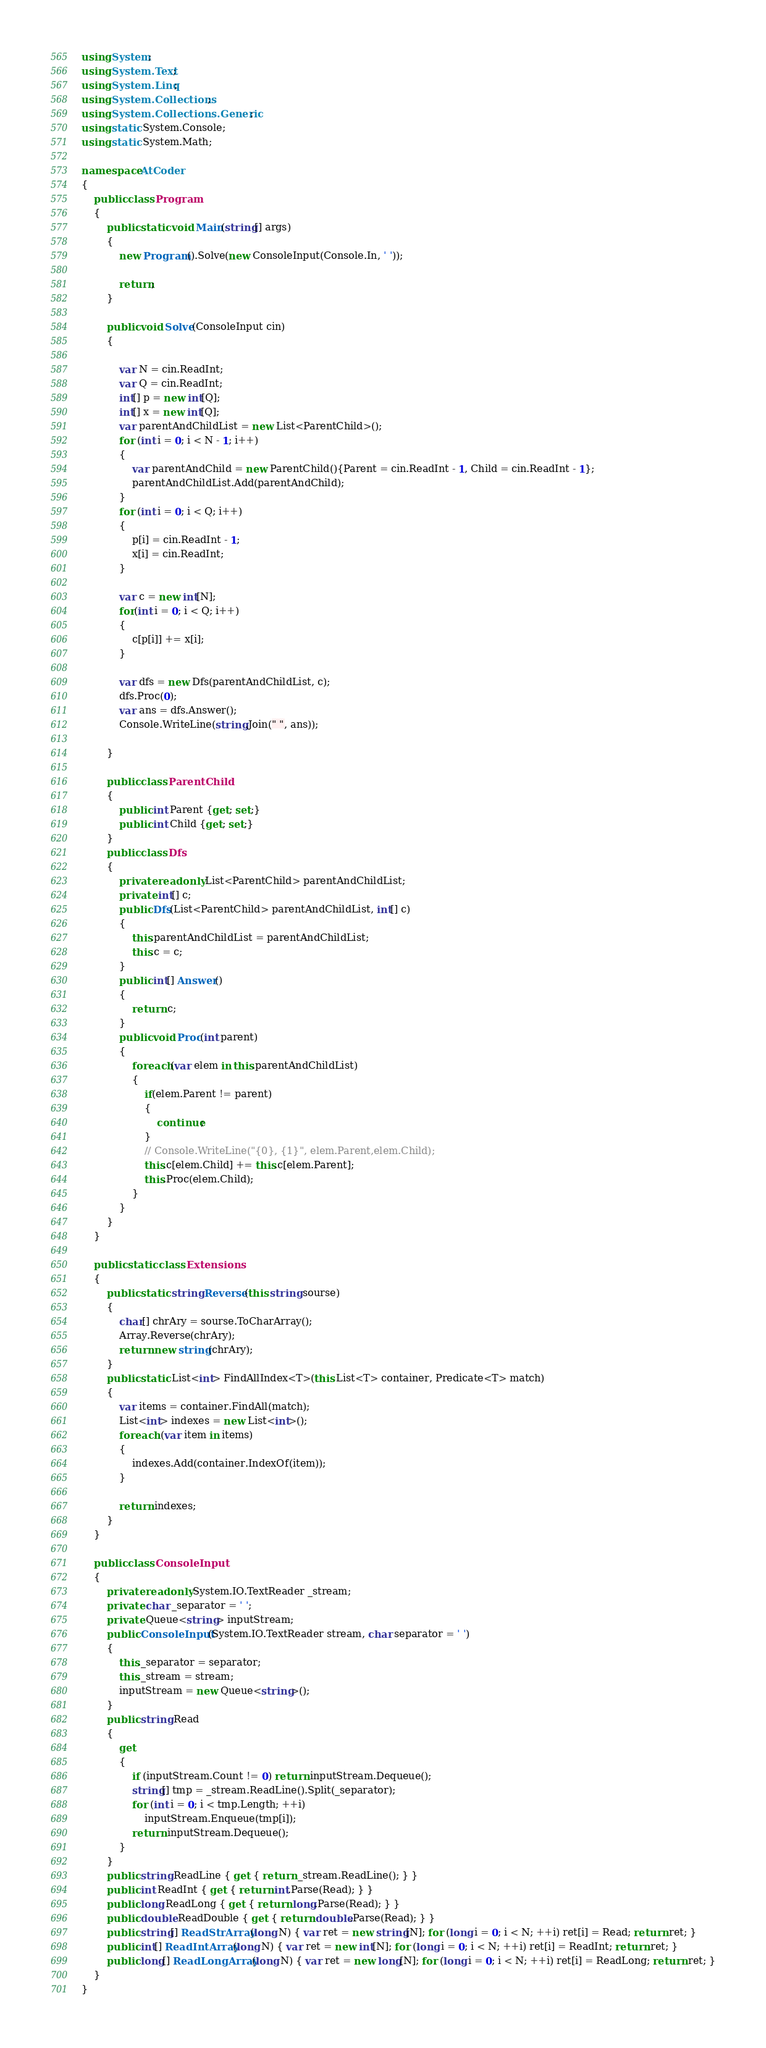<code> <loc_0><loc_0><loc_500><loc_500><_C#_>using System;
using System.Text;
using System.Linq;
using System.Collections;
using System.Collections.Generic;
using static System.Console;
using static System.Math;

namespace AtCoder
{
    public class Program
    {
        public static void Main(string[] args)
        {
            new Program().Solve(new ConsoleInput(Console.In, ' '));

            return;
        }

        public void Solve(ConsoleInput cin)
        {

            var N = cin.ReadInt;
            var Q = cin.ReadInt;
            int[] p = new int[Q];
            int[] x = new int[Q];
            var parentAndChildList = new List<ParentChild>();
            for (int i = 0; i < N - 1; i++)
            {
                var parentAndChild = new ParentChild(){Parent = cin.ReadInt - 1, Child = cin.ReadInt - 1};
                parentAndChildList.Add(parentAndChild);
            }
            for (int i = 0; i < Q; i++)
            {
                p[i] = cin.ReadInt - 1;
                x[i] = cin.ReadInt;
            }

            var c = new int[N];
            for(int i = 0; i < Q; i++)
            {
                c[p[i]] += x[i];
            }

            var dfs = new Dfs(parentAndChildList, c);
            dfs.Proc(0);
            var ans = dfs.Answer();
            Console.WriteLine(string.Join(" ", ans));

        }

        public class ParentChild
        {
            public int Parent {get; set;}
            public int Child {get; set;}
        }
        public class Dfs
        {
            private readonly List<ParentChild> parentAndChildList;
            private int[] c;
            public Dfs(List<ParentChild> parentAndChildList, int[] c)
            {
                this.parentAndChildList = parentAndChildList;
                this.c = c;
            }
            public int[] Answer()
            {
                return c;
            }
            public void Proc(int parent)
            {
                foreach(var elem in this.parentAndChildList)
                {
                    if(elem.Parent != parent)
                    {
                        continue;
                    }
                    // Console.WriteLine("{0}, {1}", elem.Parent,elem.Child);
                    this.c[elem.Child] += this.c[elem.Parent];
                    this.Proc(elem.Child);
                }
            }
        }
    }

    public static class Extensions
    {
        public static string Reverse(this string sourse)
        {
            char[] chrAry = sourse.ToCharArray();
            Array.Reverse(chrAry);
            return new string(chrAry);
        }
        public static List<int> FindAllIndex<T>(this List<T> container, Predicate<T> match)
        {
            var items = container.FindAll(match);
            List<int> indexes = new List<int>();
            foreach (var item in items)
            {
                indexes.Add(container.IndexOf(item));
            }

            return indexes;
        }
    }

    public class ConsoleInput
    {
        private readonly System.IO.TextReader _stream;
        private char _separator = ' ';
        private Queue<string> inputStream;
        public ConsoleInput(System.IO.TextReader stream, char separator = ' ')
        {
            this._separator = separator;
            this._stream = stream;
            inputStream = new Queue<string>();
        }
        public string Read
        {
            get
            {
                if (inputStream.Count != 0) return inputStream.Dequeue();
                string[] tmp = _stream.ReadLine().Split(_separator);
                for (int i = 0; i < tmp.Length; ++i)
                    inputStream.Enqueue(tmp[i]);
                return inputStream.Dequeue();
            }
        }
        public string ReadLine { get { return _stream.ReadLine(); } }
        public int ReadInt { get { return int.Parse(Read); } }
        public long ReadLong { get { return long.Parse(Read); } }
        public double ReadDouble { get { return double.Parse(Read); } }
        public string[] ReadStrArray(long N) { var ret = new string[N]; for (long i = 0; i < N; ++i) ret[i] = Read; return ret; }
        public int[] ReadIntArray(long N) { var ret = new int[N]; for (long i = 0; i < N; ++i) ret[i] = ReadInt; return ret; }
        public long[] ReadLongArray(long N) { var ret = new long[N]; for (long i = 0; i < N; ++i) ret[i] = ReadLong; return ret; }
    }
}
</code> 